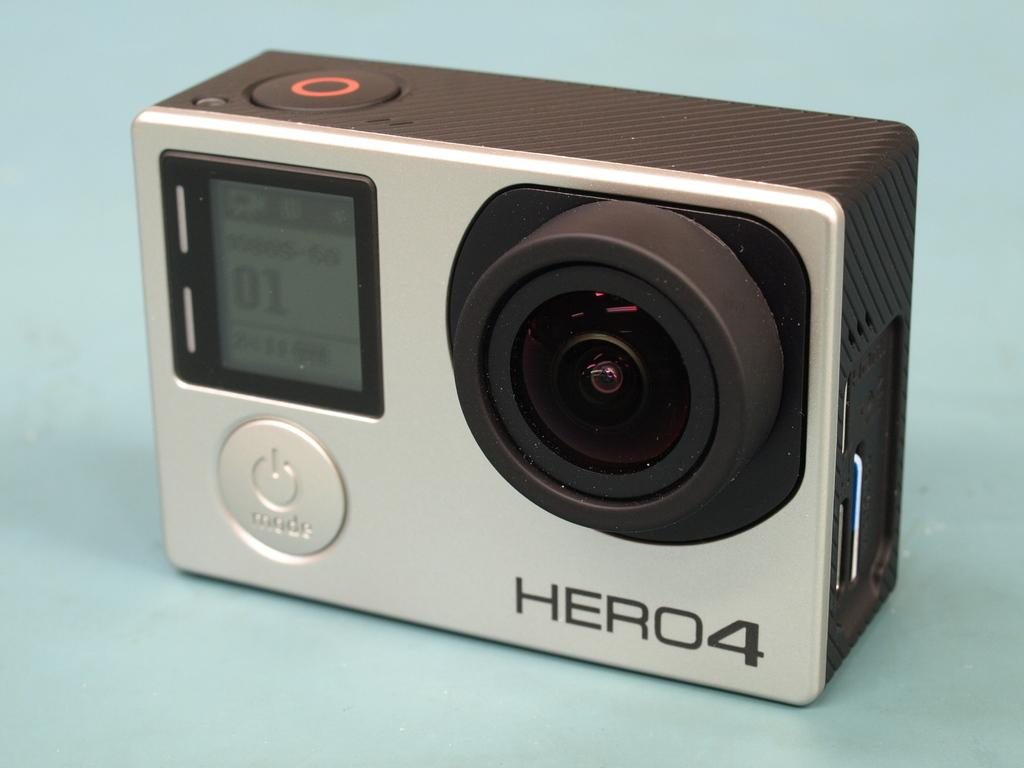What is the main subject of the image? The main subject of the image is an action camera. Can you describe the position of the action camera in the image? The action camera is on an object. What type of plate is the action camera resting on in the image? There is no plate present in the image; the action camera is on an object. How does the pocket adjust the settings of the action camera in the image? There is no pocket or adjustment of settings mentioned in the image; it only shows an action camera on an object. 